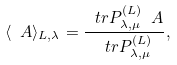<formula> <loc_0><loc_0><loc_500><loc_500>\langle \ A \rangle _ { L , \lambda } = \frac { \ t r P _ { \lambda , \mu } ^ { ( L ) } \ A } { \ t r P _ { \lambda , \mu } ^ { ( L ) } } ,</formula> 